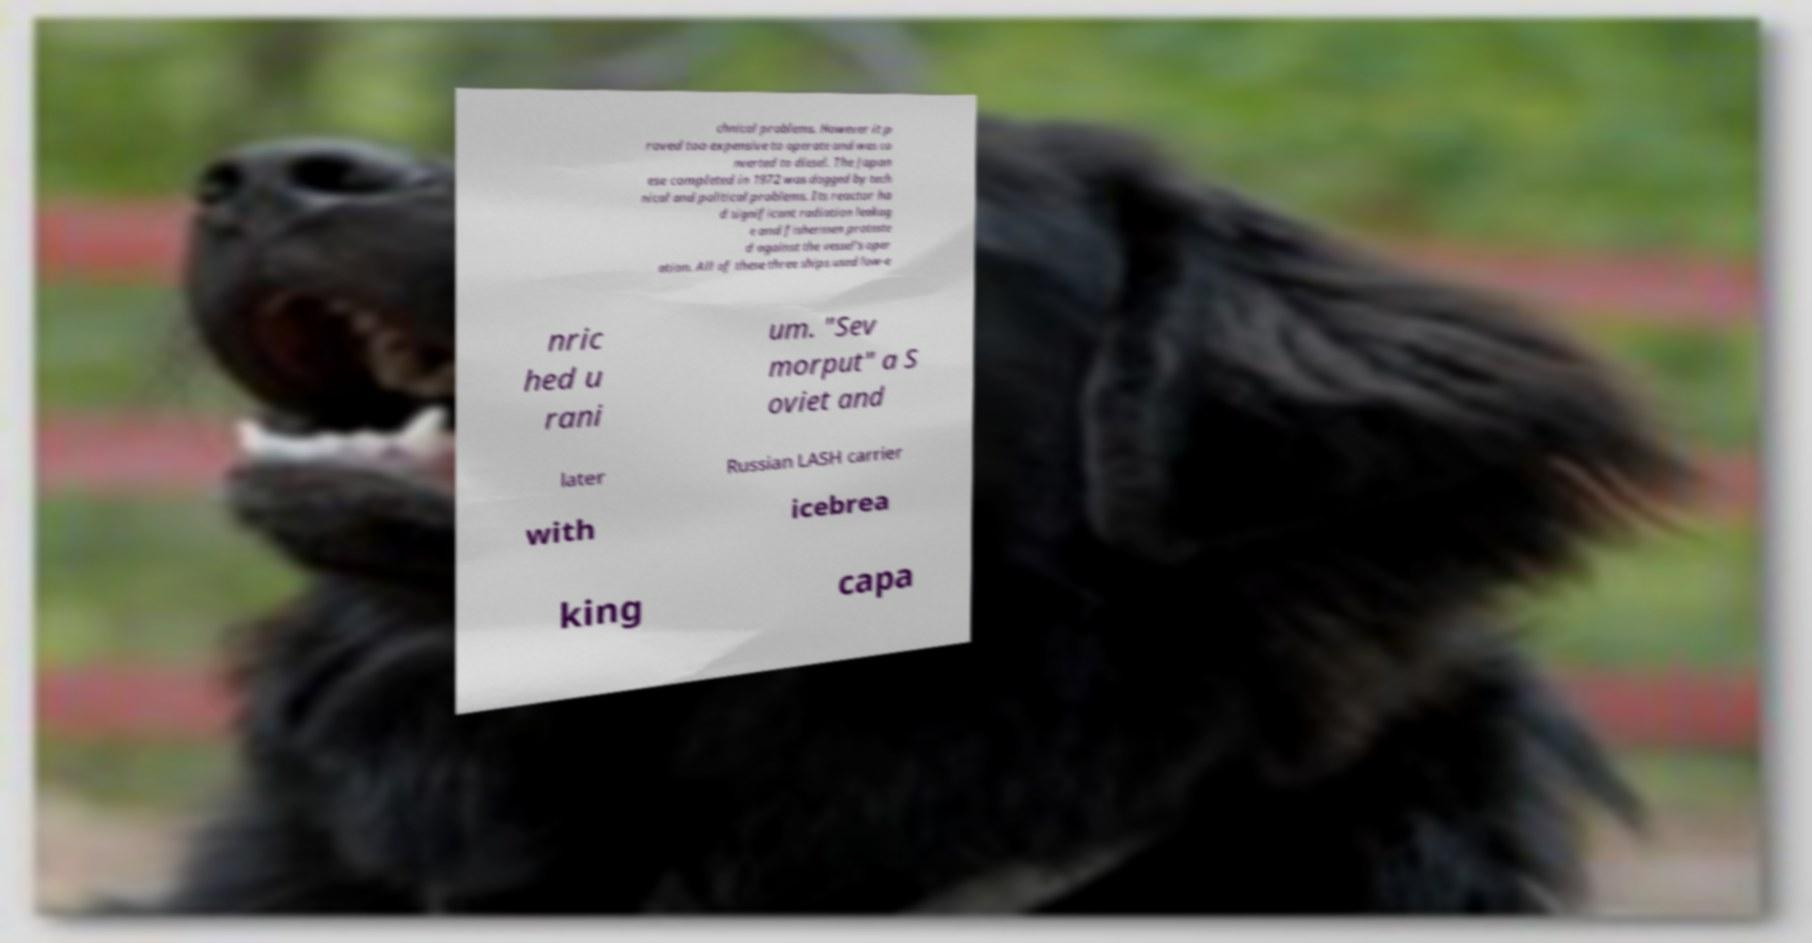Can you accurately transcribe the text from the provided image for me? chnical problems. However it p roved too expensive to operate and was co nverted to diesel. The Japan ese completed in 1972 was dogged by tech nical and political problems. Its reactor ha d significant radiation leakag e and fishermen proteste d against the vessel's oper ation. All of these three ships used low-e nric hed u rani um. "Sev morput" a S oviet and later Russian LASH carrier with icebrea king capa 